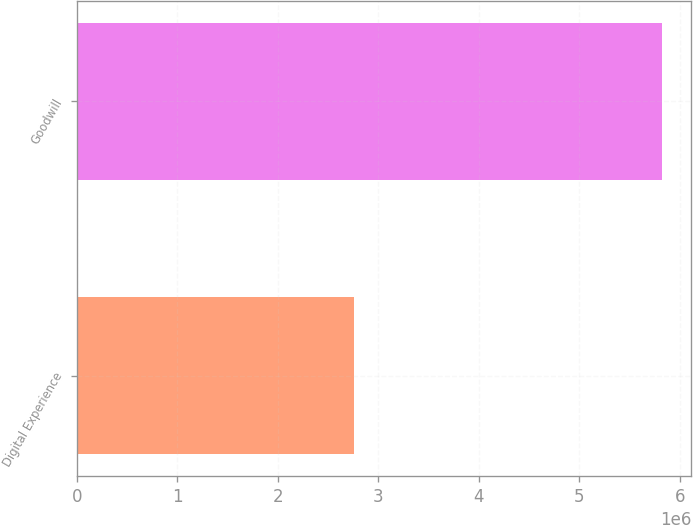Convert chart to OTSL. <chart><loc_0><loc_0><loc_500><loc_500><bar_chart><fcel>Digital Experience<fcel>Goodwill<nl><fcel>2.76205e+06<fcel>5.82156e+06<nl></chart> 